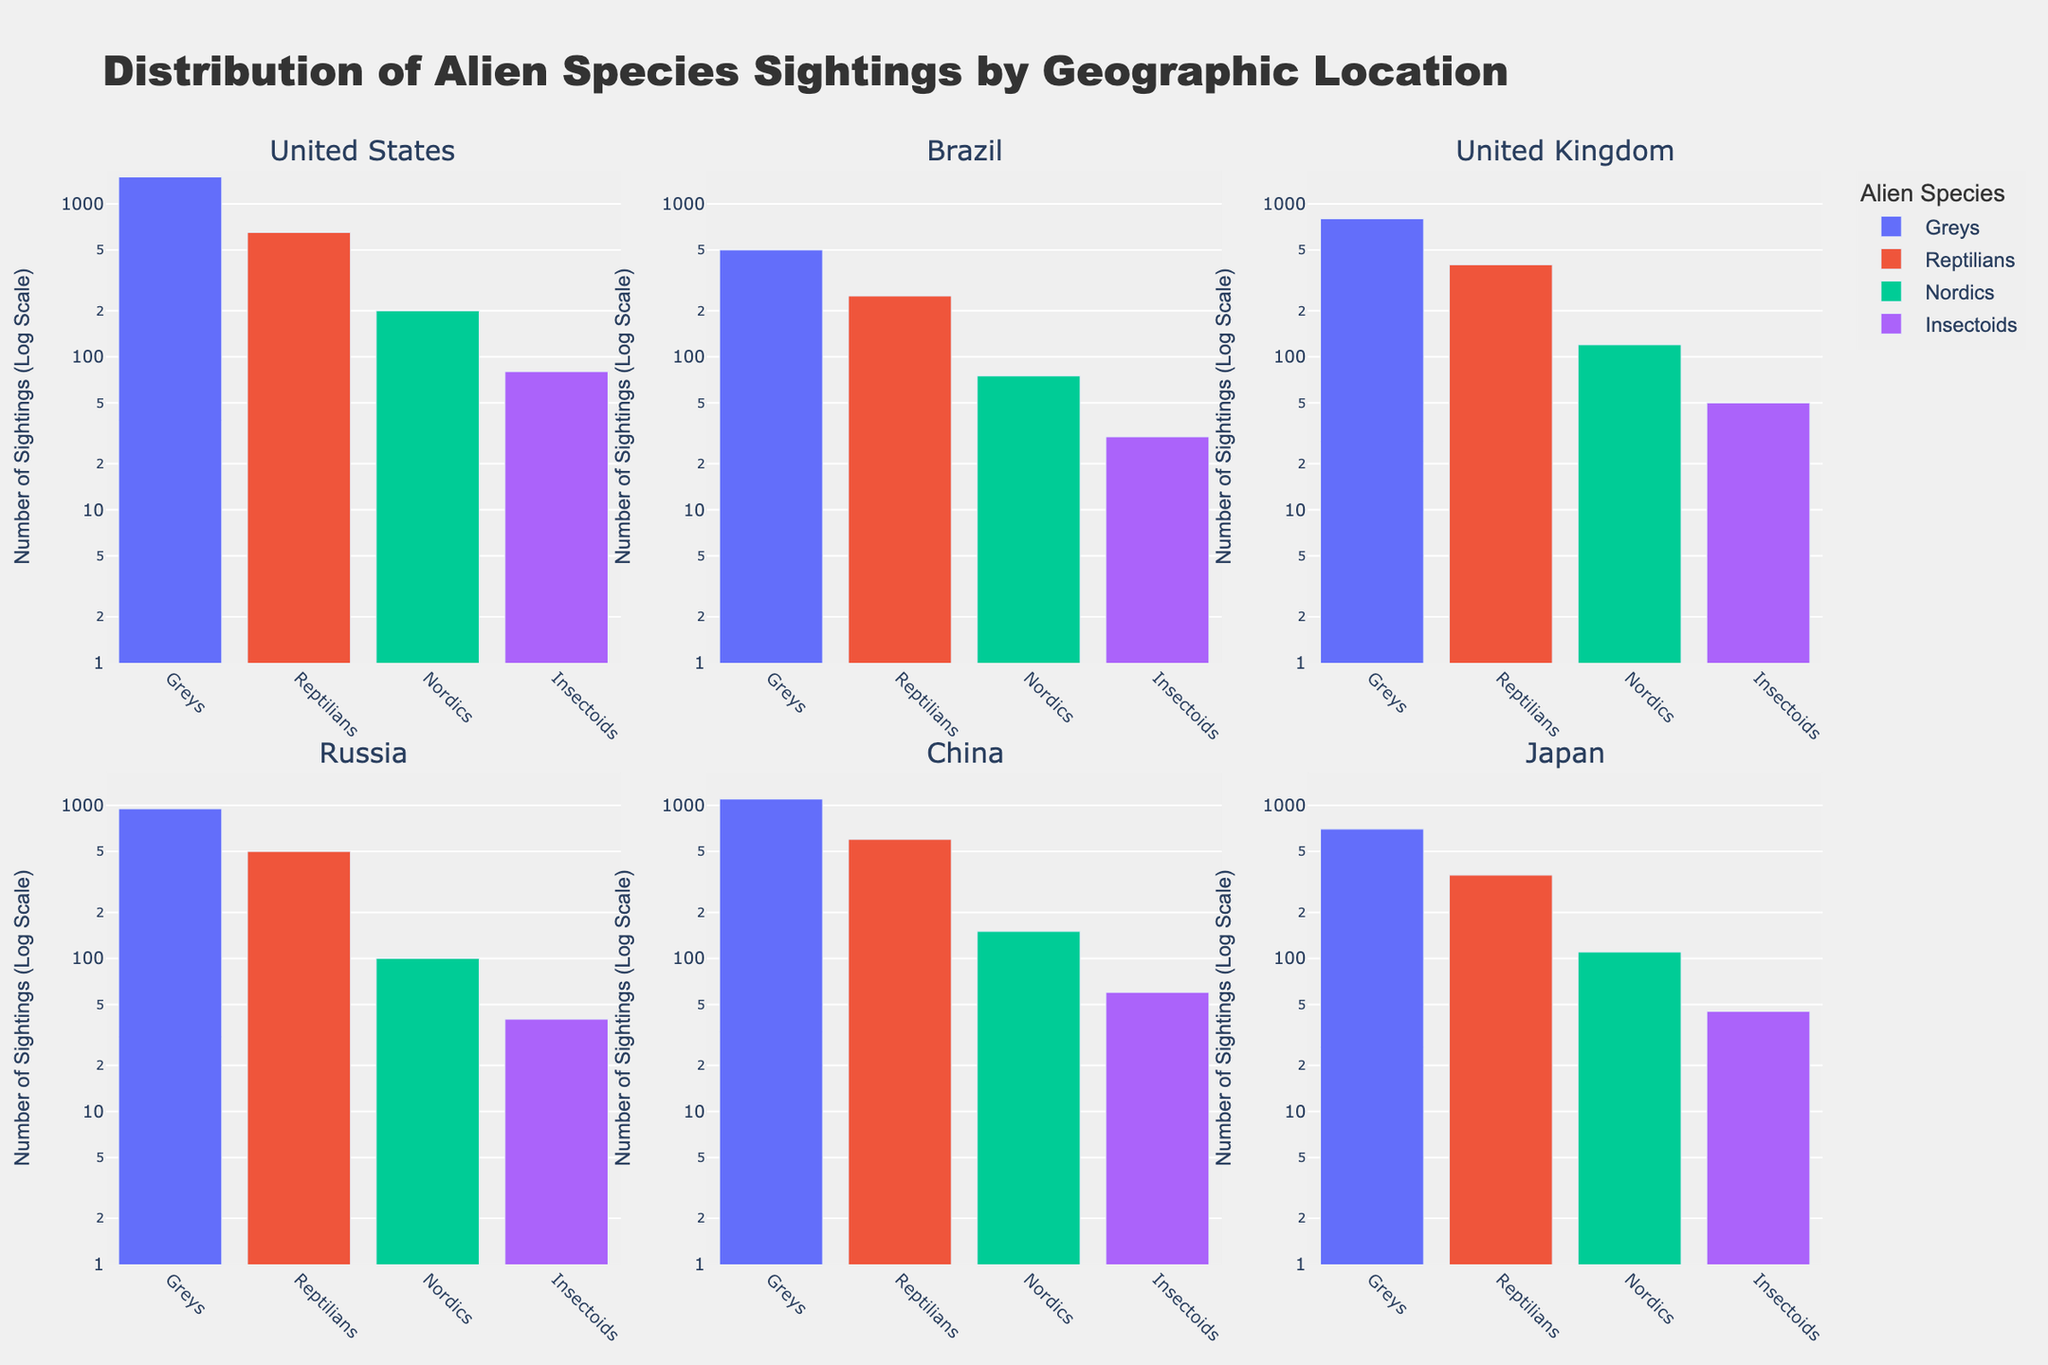What is the title of the figure? The title is displayed at the top of the figure in bold text. It reads "Distribution of Alien Species Sightings by Geographic Location."
Answer: "Distribution of Alien Species Sightings by Geographic Location." What are the labels on the y-axis? The y-axis labels are titled "Number of Sightings (Log Scale)" and use a logarithmic scale.
Answer: "Number of Sightings (Log Scale)" Which geographic location has the highest number of sightings for Greys? By comparing the height of the bars labeled "Greys" in each subplot, China has the highest number of sightings for Greys, with the bar reaching the highest point.
Answer: China How many subplots are in the figure? The figure contains 6 subplots, each labeled with a different geographic location.
Answer: 6 Which alien species have the least sightings in the United States? In the United States subplot, the bar heights for each species show that Insectoids have the least sightings.
Answer: Insectoids What is the approximate number of Reptilian sightings in Russia? In the Russia subplot, the bar for Reptilians approximates to 500 sightings.
Answer: 500 Between Brazil and Japan, which geographic location has more Nordic sightings? Comparing the heights of the Nordic bars in Brazil and Japan subplots, Brazil has 75 sightings whereas Japan has 110 sightings.
Answer: Japan What is the average number of sightings for Insectoids across all locations shown? The sightings across all locations for Insectoids are 80 (US) + 30 (Brazil) + 50 (UK) + 40 (Russia) + 60 (China) + 45 (Japan). Summing these gives 305, then dividing by 6 (the number of locations) yields an average.
Answer: 51.67 Which alien species has the most consistent number of sightings across all geographic locations? By visually inspecting the heights of the bars for each species across all subplots, the Greys' sightings appear to be consistently the highest and most similar in each subplot.
Answer: Greys Are there any geographic locations where the Nordics sightings exceed 200? By looking at the bars labeled "Nordics" across all subplots, none of the locations have Nordic sightings that exceed 200.
Answer: No 